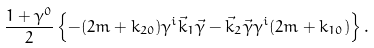<formula> <loc_0><loc_0><loc_500><loc_500>\frac { 1 + \gamma ^ { 0 } } 2 \left \{ - ( 2 m + k _ { 2 0 } ) \gamma ^ { i } \vec { k } _ { 1 } \vec { \gamma } - \vec { k } _ { 2 } \vec { \gamma } \gamma ^ { i } ( 2 m + k _ { 1 0 } ) \right \} .</formula> 